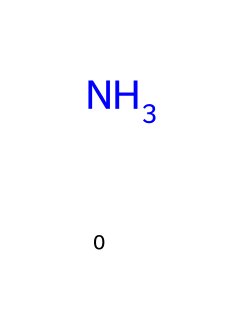What is the chemical name of this compound? The SMILES representation shows a single nitrogen atom, which is indicative of ammonia (NH3). This means the chemical name can be directly derived from the nitrogen alone.
Answer: ammonia How many hydrogen atoms are bonded to the nitrogen atom in ammonia? The chemical structure of ammonia typically involves one nitrogen atom and three hydrogen atoms bonded to it, even though only the nitrogen is represented in the SMILES notation.
Answer: three What type of bond exists in ammonia between nitrogen and hydrogen? Ammonia consists of covalent bonds where the nitrogen atom shares electrons with three hydrogen atoms. This bond type can be inferred based on the structure involving nitrogen and hydrogen.
Answer: covalent Why is ammonia important for global agriculture? Ammonia plays a key role in fertilizers due to its nitrogen content, which is essential for plant growth and development. The significance comes from understanding that nitrogen is a critical nutrient for plants.
Answer: nitrogen source What is the role of ammonia in the nitrogen cycle? Ammonia is part of the nitrogen cycle as it is produced through nitrogen fixation and then either taken up by plants or converted by bacteria into other nitrogen compounds, illustrating its crucial involvement in maintaining soil fertility.
Answer: nitrogen fixation How does the presence of ammonia affect soil acidity? Ammonia can increase soil acidity upon its conversion to nitrates through microbial activity, which generates hydrogen ions, leading to a more acidic soil environment. This can be derived from understanding the chemical interactions in the soil environment.
Answer: increase acidity 